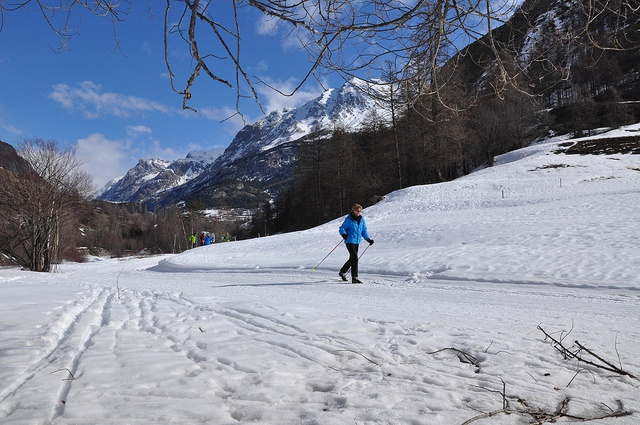Describe the objects in this image and their specific colors. I can see people in blue, black, gray, and navy tones, people in blue, black, gray, darkgreen, and olive tones, people in blue, navy, darkblue, and gray tones, people in blue, black, maroon, gray, and purple tones, and people in blue, black, gray, and darkgreen tones in this image. 